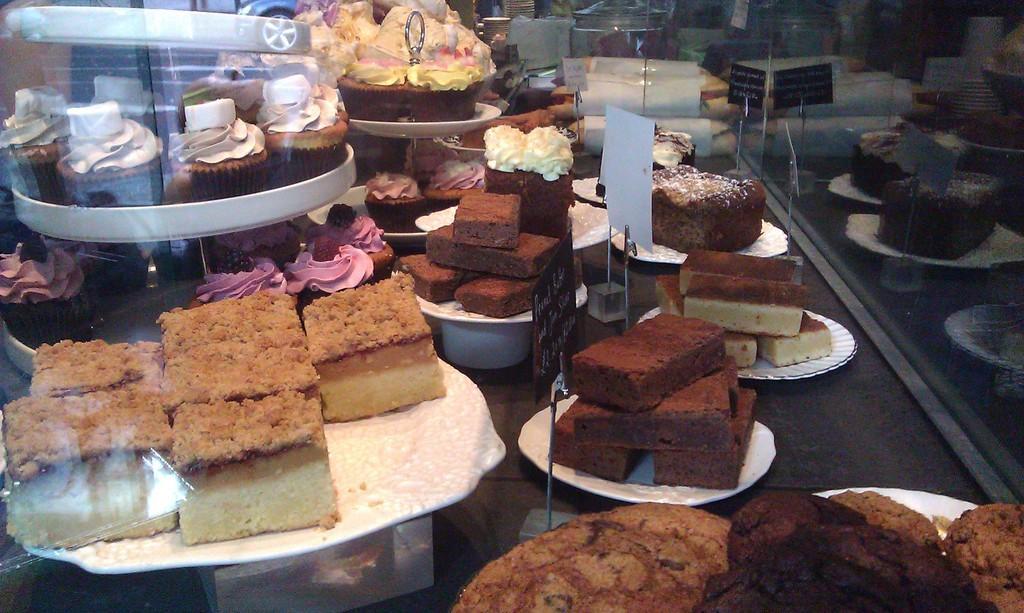How would you summarize this image in a sentence or two? In this image there are plates in that plates there are sweets and cakes. 